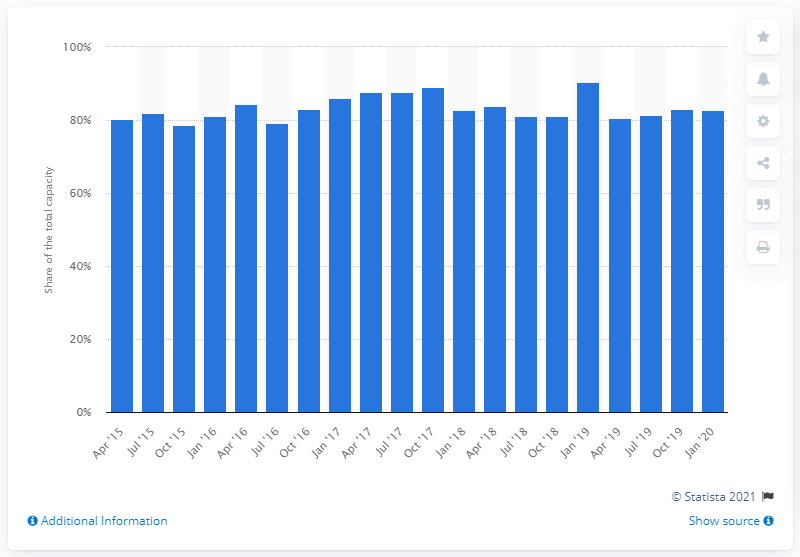Draw attention to some important aspects in this diagram. In January 2020, the Dutch clothing manufacturing industry used 82.7% of its total quality. 